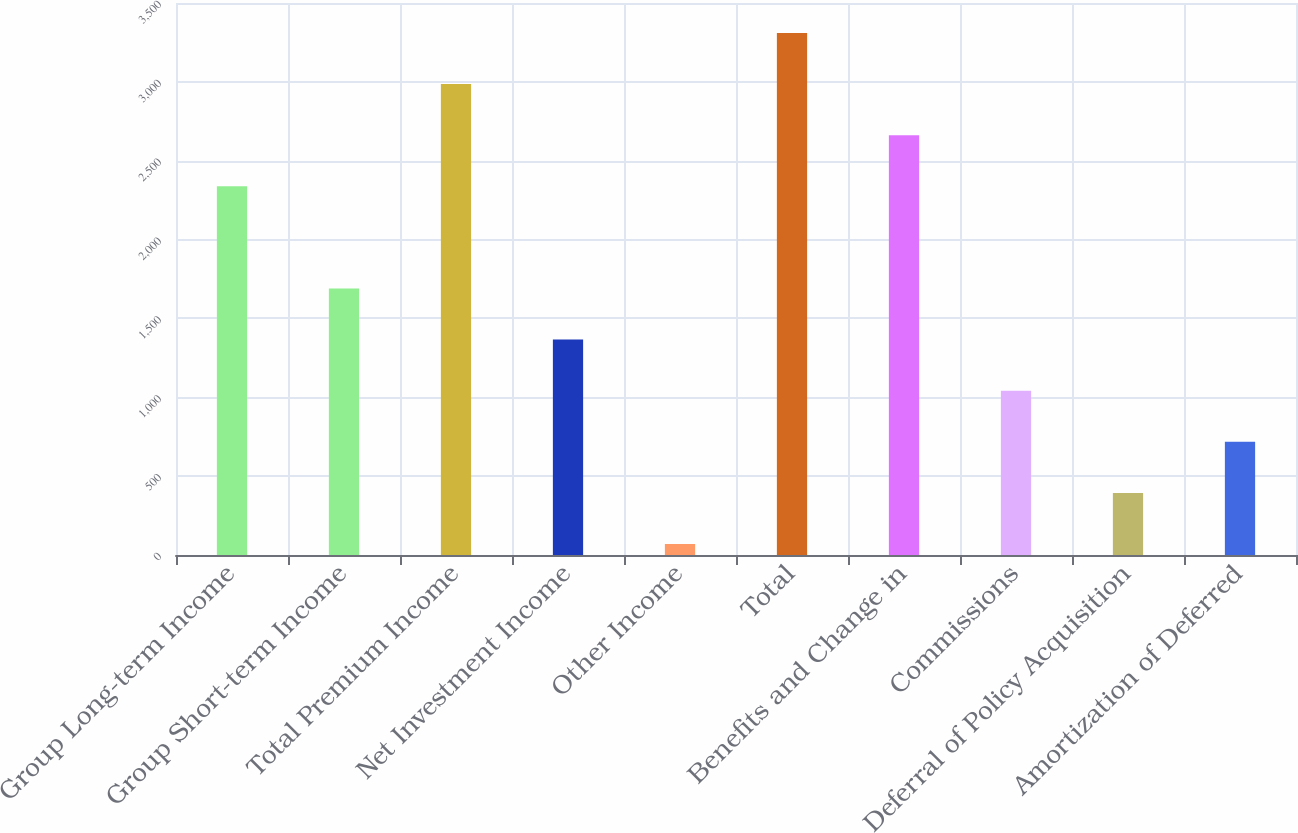<chart> <loc_0><loc_0><loc_500><loc_500><bar_chart><fcel>Group Long-term Income<fcel>Group Short-term Income<fcel>Total Premium Income<fcel>Net Investment Income<fcel>Other Income<fcel>Total<fcel>Benefits and Change in<fcel>Commissions<fcel>Deferral of Policy Acquisition<fcel>Amortization of Deferred<nl><fcel>2337.95<fcel>1689.85<fcel>2986.05<fcel>1365.8<fcel>69.6<fcel>3310.1<fcel>2662<fcel>1041.75<fcel>393.65<fcel>717.7<nl></chart> 